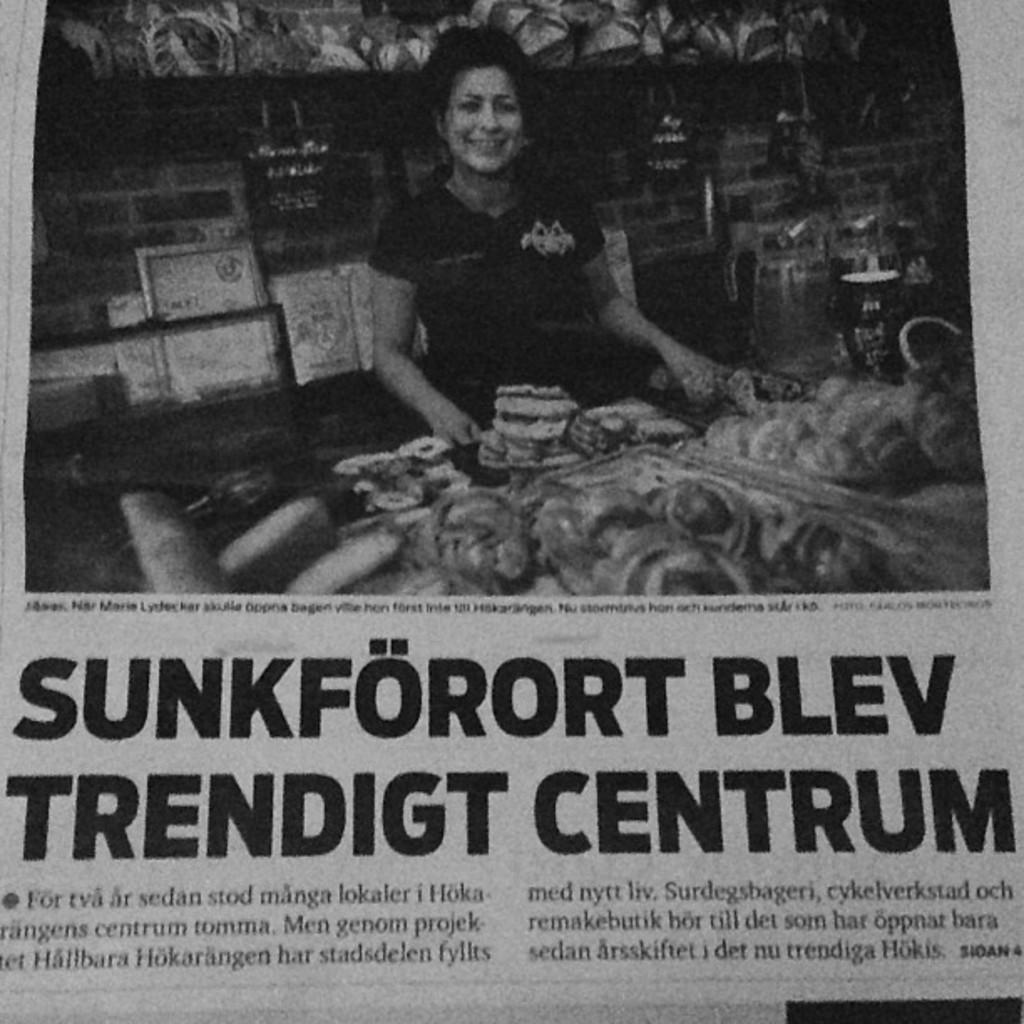<image>
Write a terse but informative summary of the picture. A foreign language paper that says Sunkforort Blev. 